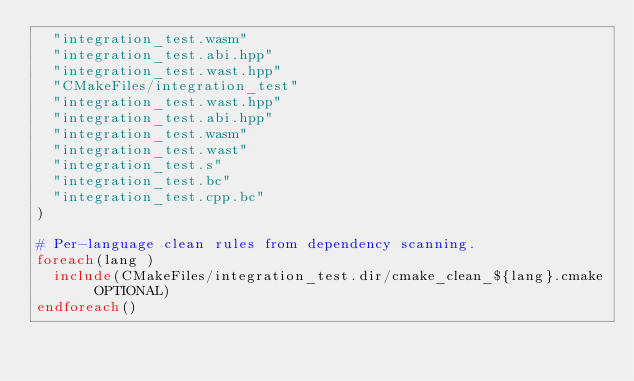Convert code to text. <code><loc_0><loc_0><loc_500><loc_500><_CMake_>  "integration_test.wasm"
  "integration_test.abi.hpp"
  "integration_test.wast.hpp"
  "CMakeFiles/integration_test"
  "integration_test.wast.hpp"
  "integration_test.abi.hpp"
  "integration_test.wasm"
  "integration_test.wast"
  "integration_test.s"
  "integration_test.bc"
  "integration_test.cpp.bc"
)

# Per-language clean rules from dependency scanning.
foreach(lang )
  include(CMakeFiles/integration_test.dir/cmake_clean_${lang}.cmake OPTIONAL)
endforeach()
</code> 